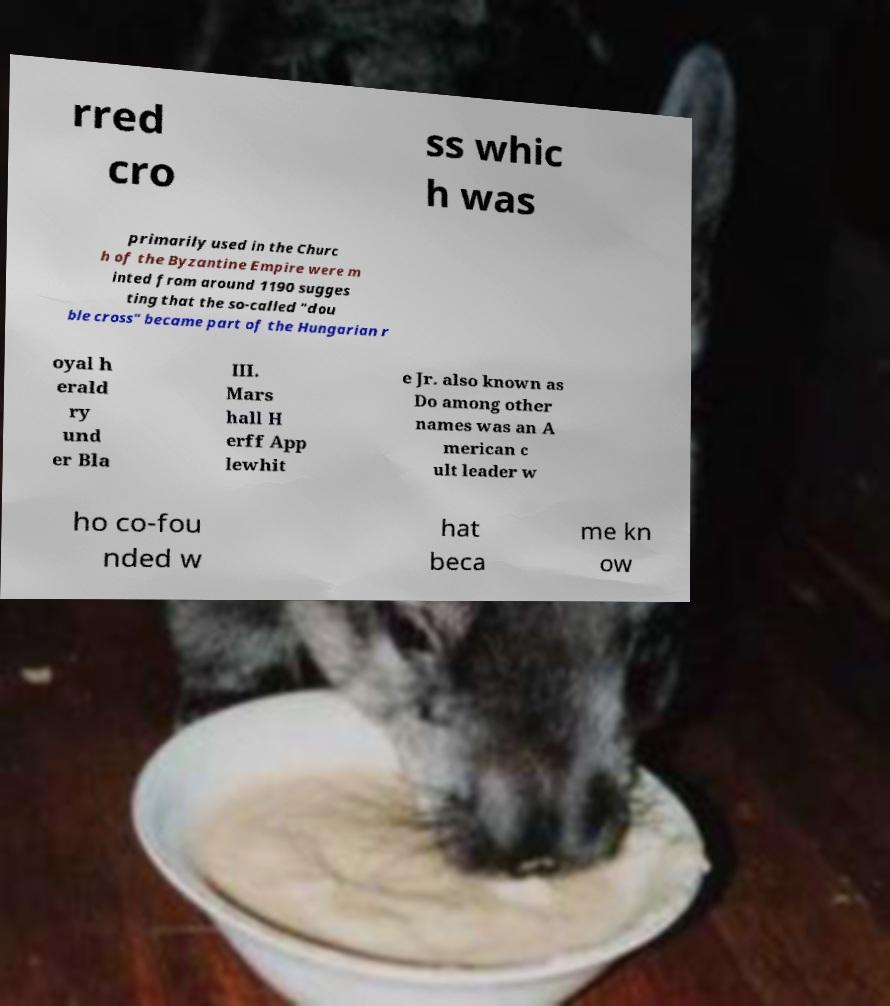There's text embedded in this image that I need extracted. Can you transcribe it verbatim? rred cro ss whic h was primarily used in the Churc h of the Byzantine Empire were m inted from around 1190 sugges ting that the so-called "dou ble cross" became part of the Hungarian r oyal h erald ry und er Bla III. Mars hall H erff App lewhit e Jr. also known as Do among other names was an A merican c ult leader w ho co-fou nded w hat beca me kn ow 